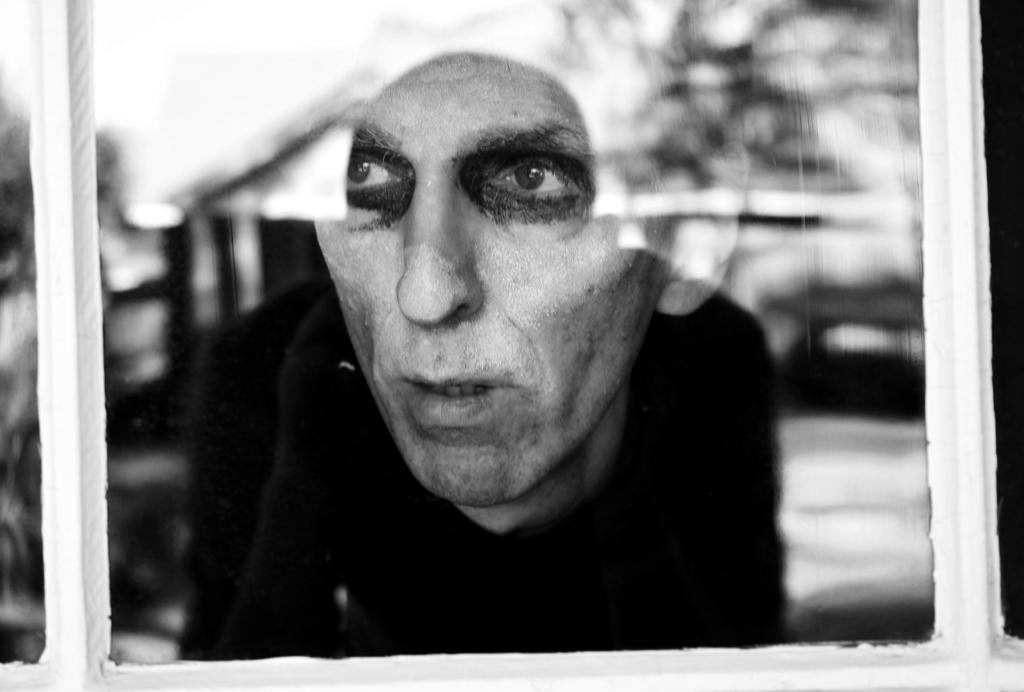What can be seen through the window in the image? A person's face is visible behind the window. Are there any other elements visible through the window? Yes, there is a reflection of trees on the window. What type of list can be seen in the image? There is no list present in the image. 